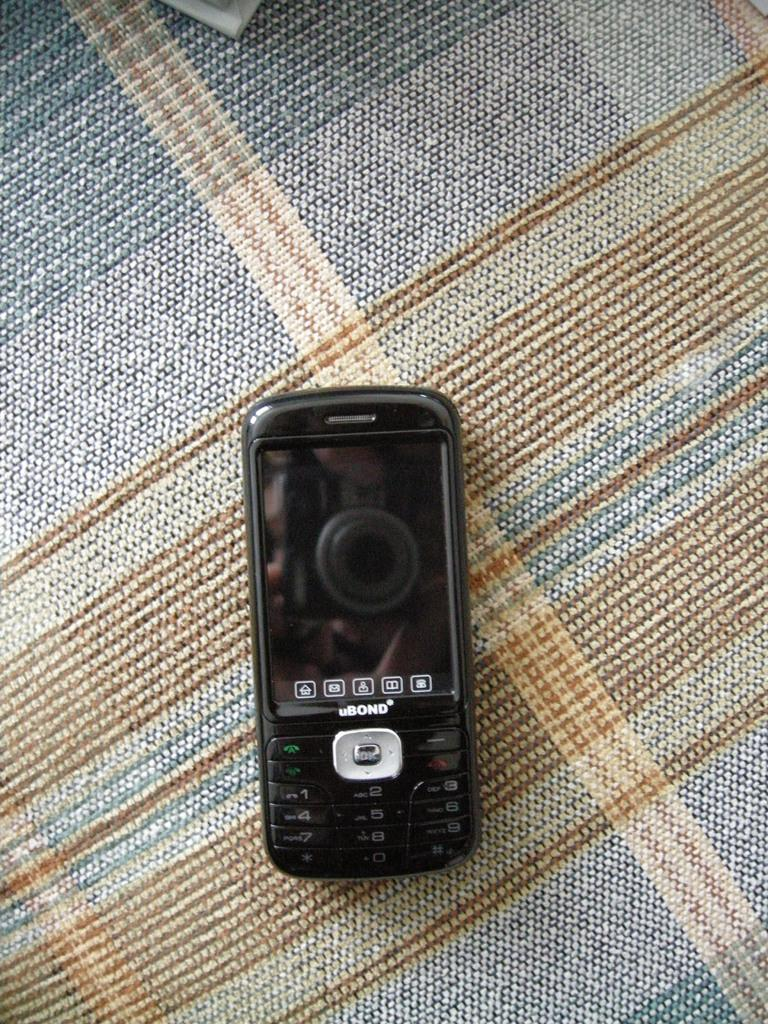What electronic device is present in the image? There is a mobile phone in the image. What is the mobile phone placed on in the image? The mobile phone is kept on a cloth. How many girls are visible in the image? There are no girls present in the image. What country is depicted in the image? There is no country depicted in the image; it only features a mobile phone on a cloth. Is there a rifle visible in the image? There is no rifle present in the image. 